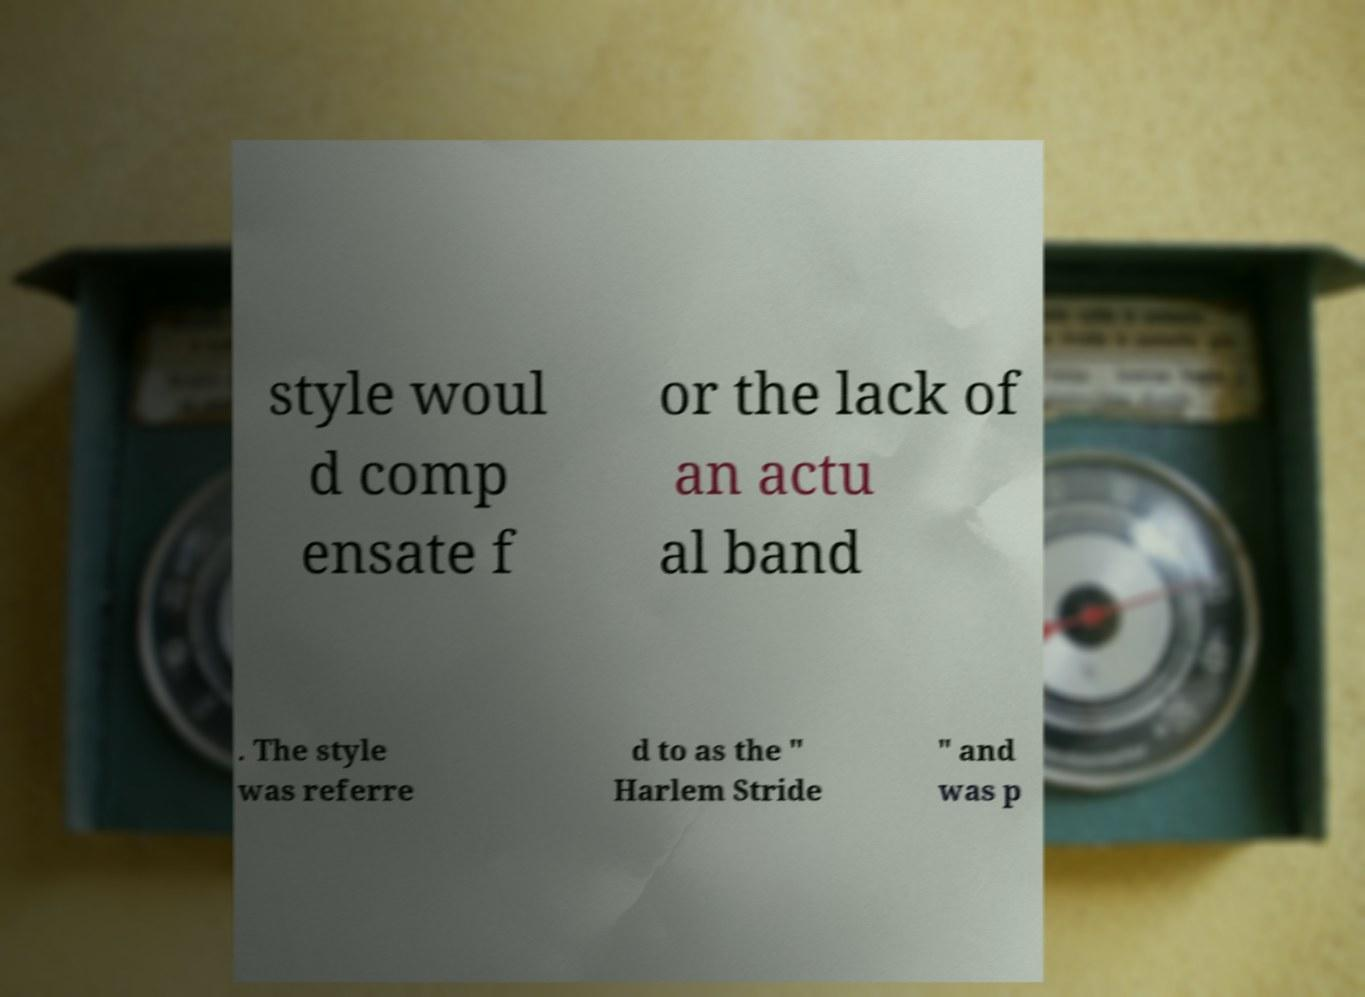There's text embedded in this image that I need extracted. Can you transcribe it verbatim? style woul d comp ensate f or the lack of an actu al band . The style was referre d to as the " Harlem Stride " and was p 